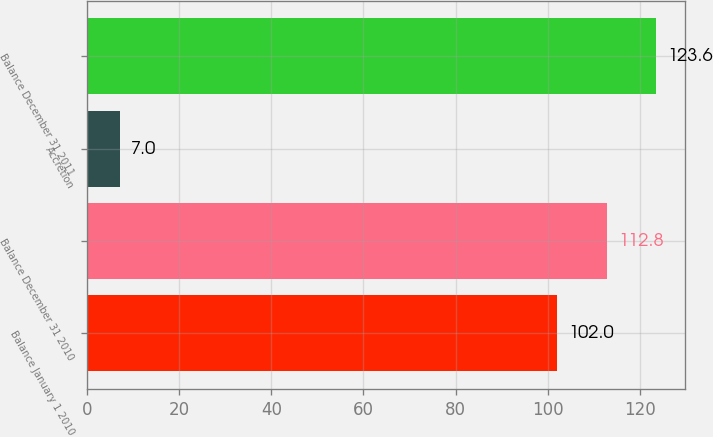<chart> <loc_0><loc_0><loc_500><loc_500><bar_chart><fcel>Balance January 1 2010<fcel>Balance December 31 2010<fcel>Accretion<fcel>Balance December 31 2011<nl><fcel>102<fcel>112.8<fcel>7<fcel>123.6<nl></chart> 